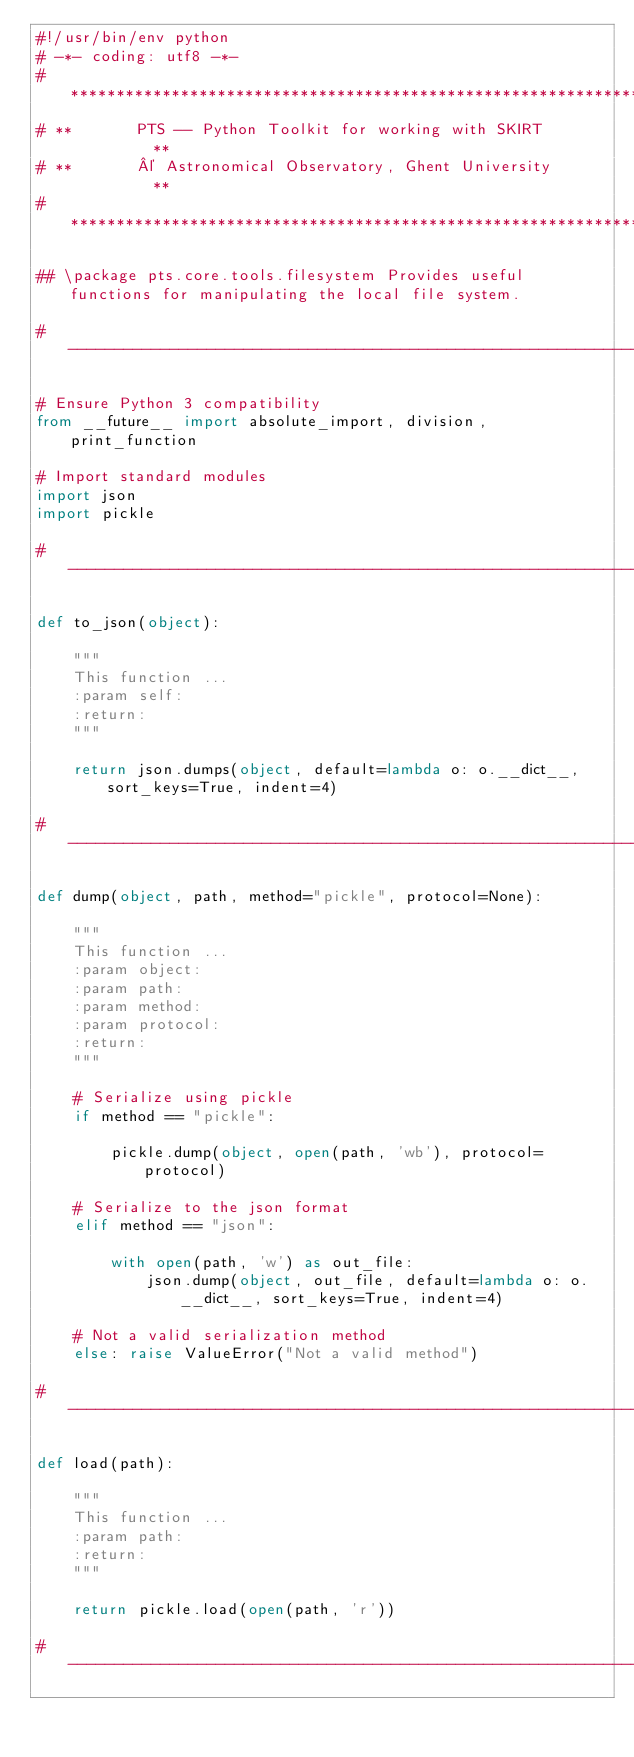Convert code to text. <code><loc_0><loc_0><loc_500><loc_500><_Python_>#!/usr/bin/env python
# -*- coding: utf8 -*-
# *****************************************************************
# **       PTS -- Python Toolkit for working with SKIRT          **
# **       © Astronomical Observatory, Ghent University          **
# *****************************************************************

## \package pts.core.tools.filesystem Provides useful functions for manipulating the local file system.

# -----------------------------------------------------------------

# Ensure Python 3 compatibility
from __future__ import absolute_import, division, print_function

# Import standard modules
import json
import pickle

# -----------------------------------------------------------------

def to_json(object):

    """
    This function ...
    :param self:
    :return:
    """

    return json.dumps(object, default=lambda o: o.__dict__, sort_keys=True, indent=4)

# -----------------------------------------------------------------

def dump(object, path, method="pickle", protocol=None):

    """
    This function ...
    :param object:
    :param path:
    :param method:
    :param protocol:
    :return:
    """

    # Serialize using pickle
    if method == "pickle":

        pickle.dump(object, open(path, 'wb'), protocol=protocol)

    # Serialize to the json format
    elif method == "json":

        with open(path, 'w') as out_file:
            json.dump(object, out_file, default=lambda o: o.__dict__, sort_keys=True, indent=4)

    # Not a valid serialization method
    else: raise ValueError("Not a valid method")

# -----------------------------------------------------------------

def load(path):

    """
    This function ...
    :param path:
    :return:
    """

    return pickle.load(open(path, 'r'))

# -----------------------------------------------------------------
</code> 